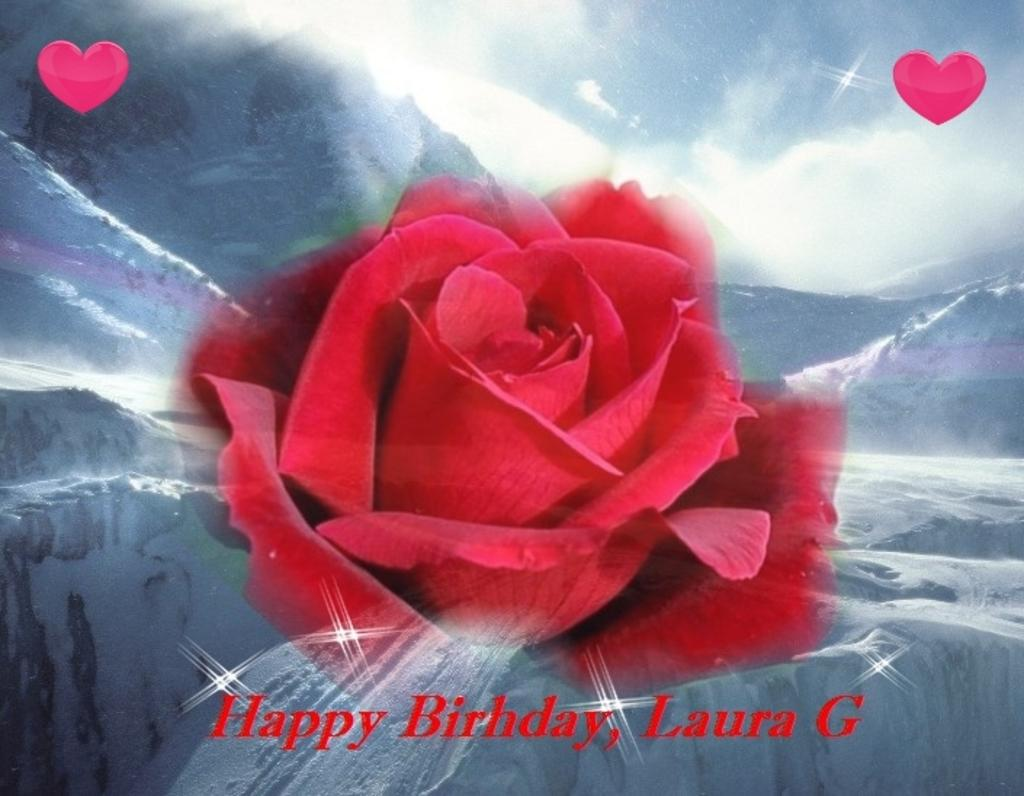What is depicted on the poster in the image? The poster contains a rose flower. Are there any words or phrases on the poster? Yes, the poster has text on it. What other elements are included on the poster? The poster includes symbols of heart. What can be seen in the distance in the image? There are mountains in the background of the image. What songs can be heard playing in the background of the image? There is no audio or music present in the image, so it is not possible to determine what songs might be heard. 